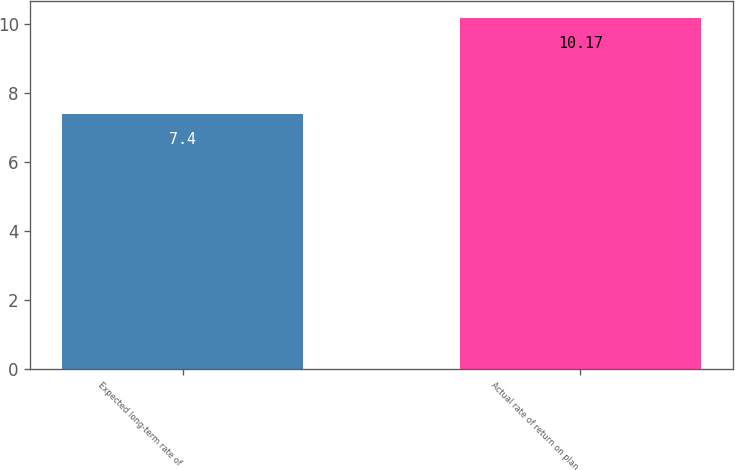<chart> <loc_0><loc_0><loc_500><loc_500><bar_chart><fcel>Expected long-term rate of<fcel>Actual rate of return on plan<nl><fcel>7.4<fcel>10.17<nl></chart> 